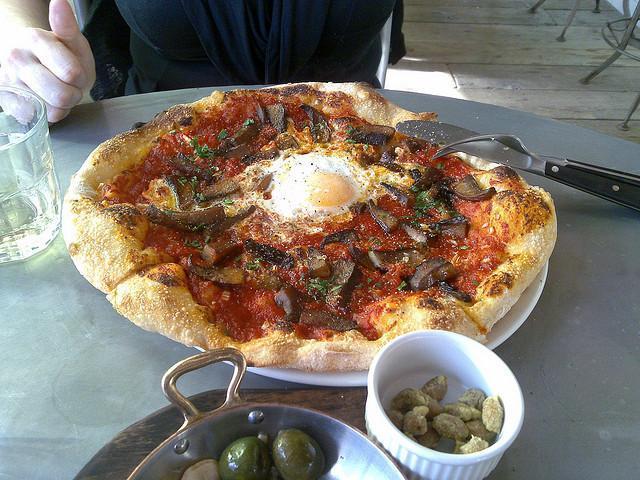How many frisbees are laying on the ground?
Give a very brief answer. 0. 